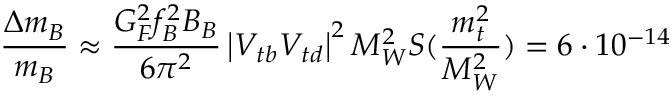Convert formula to latex. <formula><loc_0><loc_0><loc_500><loc_500>\frac { \Delta m _ { B } } { m _ { B } } \approx \frac { G _ { F } ^ { 2 } f _ { B } ^ { 2 } B _ { B } } { 6 \pi ^ { 2 } } \left | V _ { t b } V _ { t d } \right | ^ { 2 } M _ { W } ^ { 2 } S ( \frac { m _ { t } ^ { 2 } } { M _ { W } ^ { 2 } } ) = 6 \cdot 1 0 ^ { - 1 4 }</formula> 